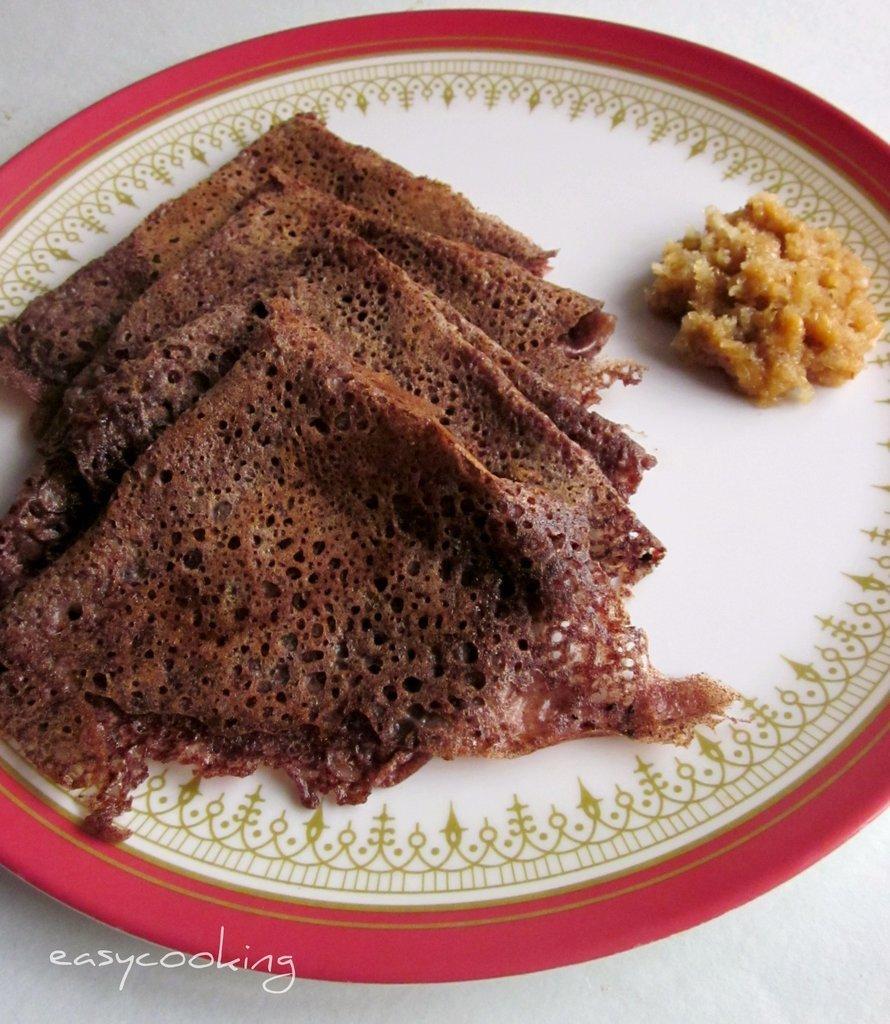Please provide a concise description of this image. In the image we can see a plate, in the plate we can see food item and the plate is kept on white surface. On the bottom left we can see watermark. 